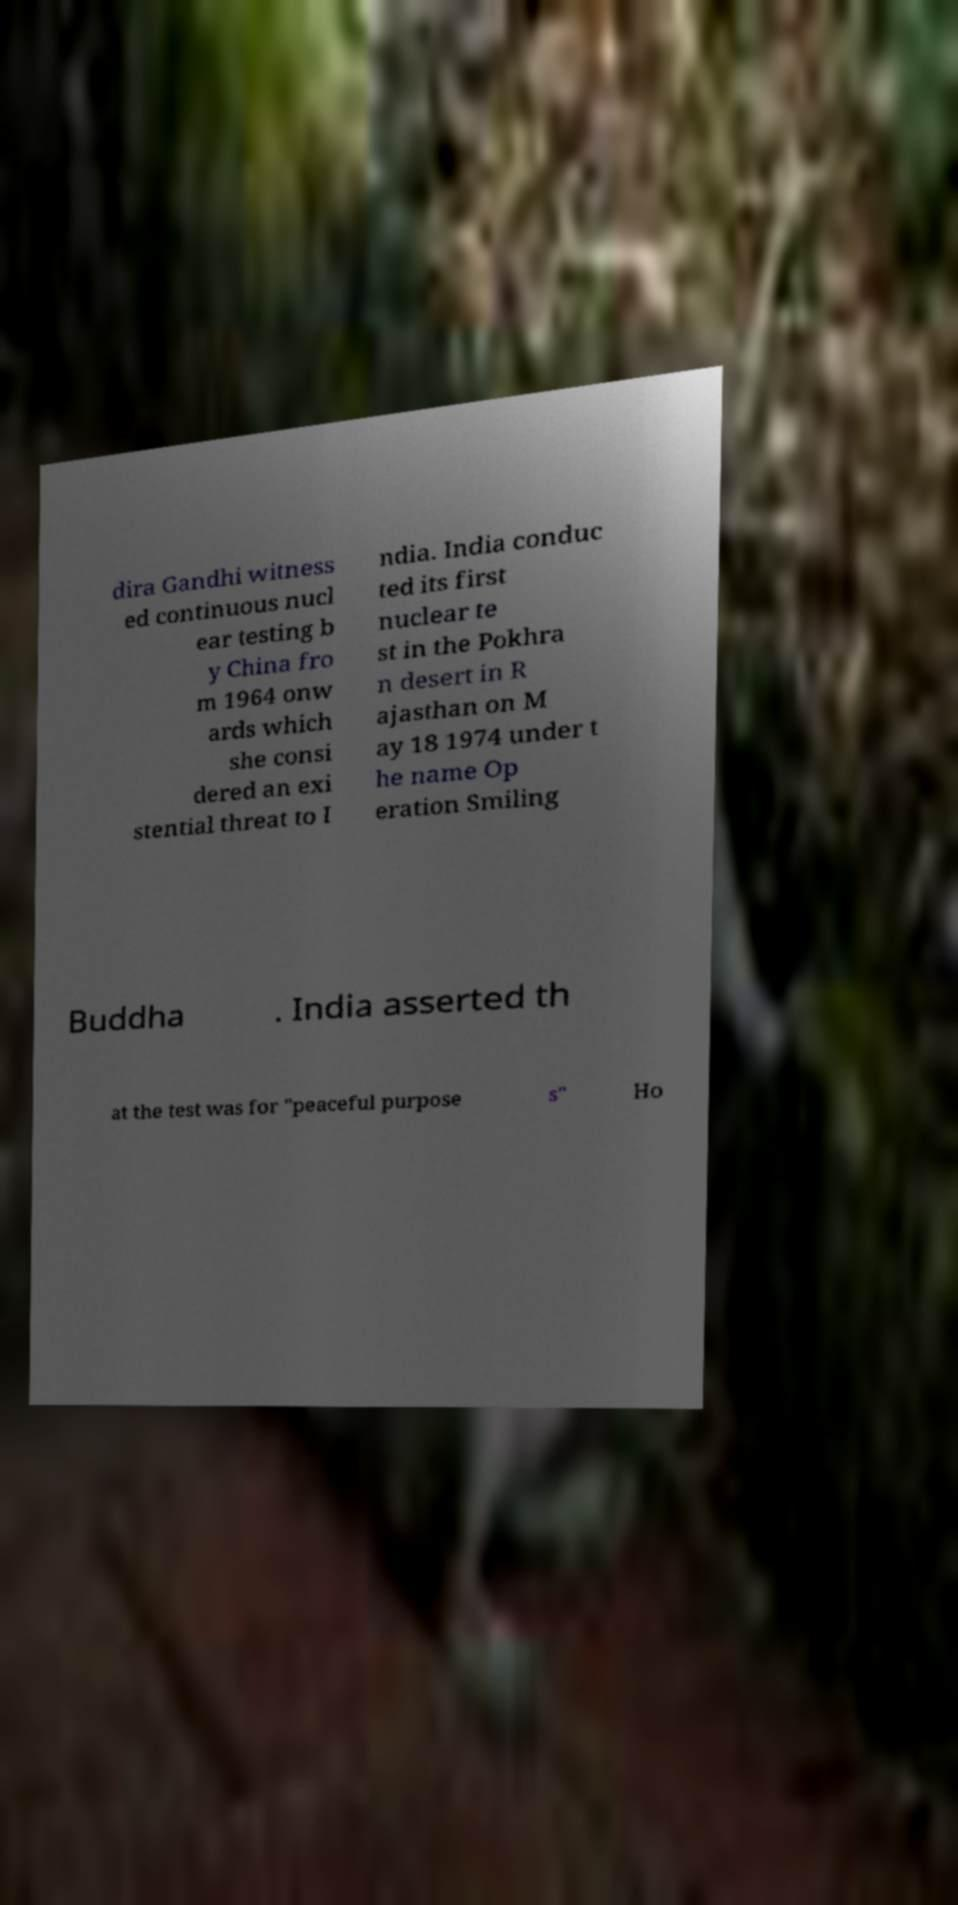Can you accurately transcribe the text from the provided image for me? dira Gandhi witness ed continuous nucl ear testing b y China fro m 1964 onw ards which she consi dered an exi stential threat to I ndia. India conduc ted its first nuclear te st in the Pokhra n desert in R ajasthan on M ay 18 1974 under t he name Op eration Smiling Buddha . India asserted th at the test was for "peaceful purpose s" Ho 